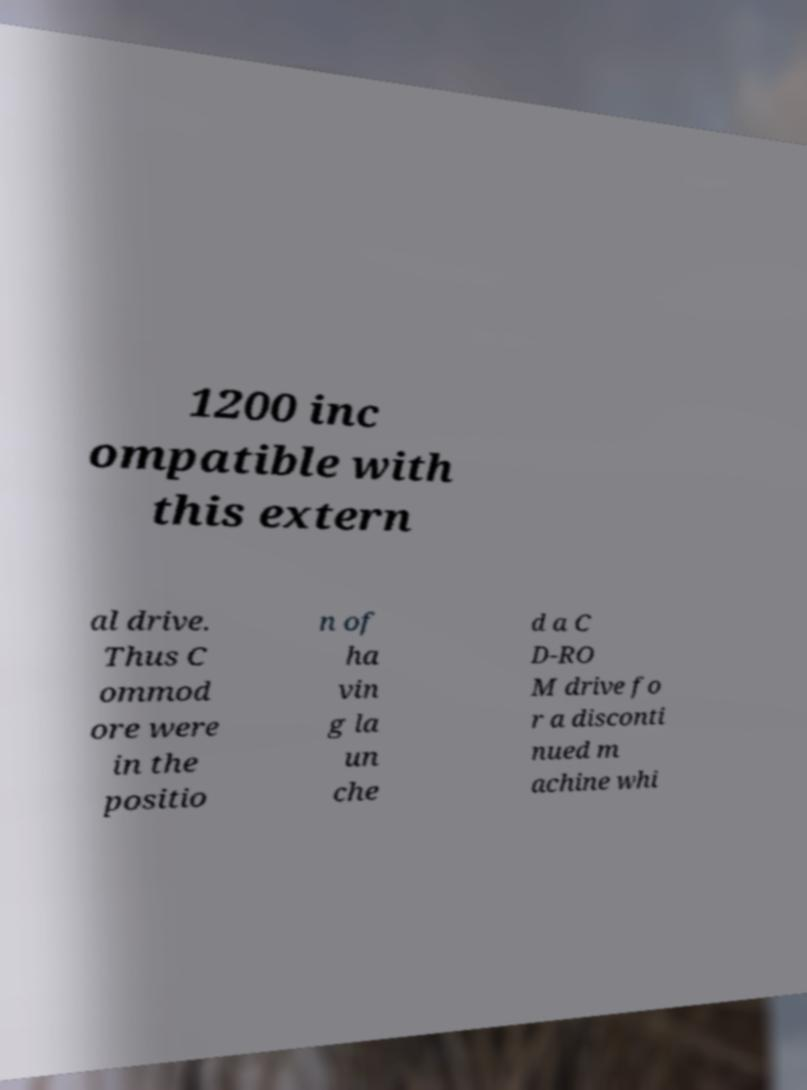Can you read and provide the text displayed in the image?This photo seems to have some interesting text. Can you extract and type it out for me? 1200 inc ompatible with this extern al drive. Thus C ommod ore were in the positio n of ha vin g la un che d a C D-RO M drive fo r a disconti nued m achine whi 